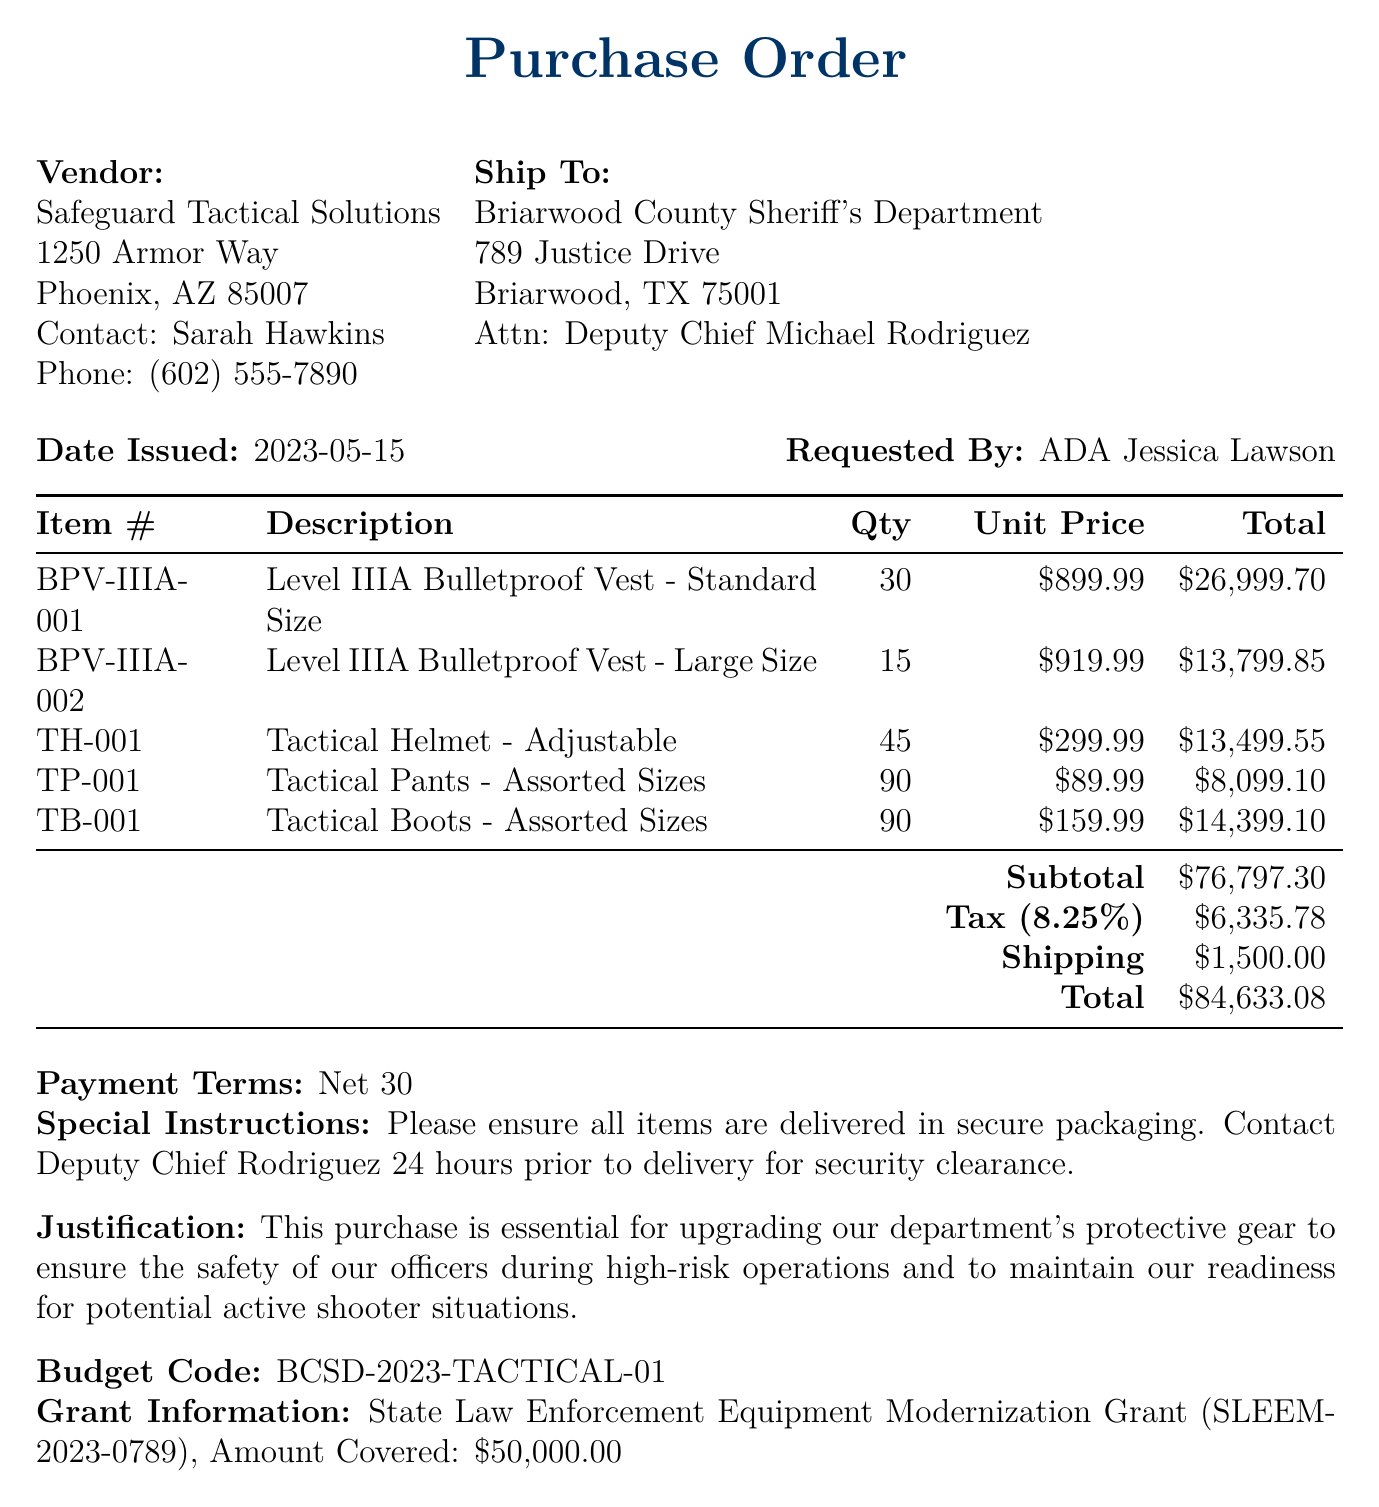What is the PO number? The PO number is specified in the document as BCSD-2023-0542.
Answer: BCSD-2023-0542 Who is the vendor? The vendor's name is mentioned in the document as Safeguard Tactical Solutions.
Answer: Safeguard Tactical Solutions What is the total amount of the purchase? The total amount is stated at the bottom of the document as $84,633.08.
Answer: $84,633.08 Who approved the purchase? The document lists Sheriff Thomas Grayson as the person who approved the purchase.
Answer: Sheriff Thomas Grayson What kind of gear is being purchased? The gear includes bulletproof vests, tactical helmets, pants, and boots as detailed in the items section.
Answer: Bulletproof vests, tactical helmets, pants, and boots What is the justification for this purchase? The justification includes upgrading protective gear for officer safety during high-risk operations.
Answer: Upgrading protective gear for officer safety What is the tax rate applied to this purchase? The document states the tax rate as 8.25%.
Answer: 8.25% When was the purchase order issued? The issuance date of the purchase order is given as May 15, 2023.
Answer: May 15, 2023 What is the special instruction regarding delivery? The document instructs that the vendor must contact Deputy Chief Rodriguez for security clearance prior to delivery.
Answer: Contact Deputy Chief Rodriguez for security clearance before delivery 